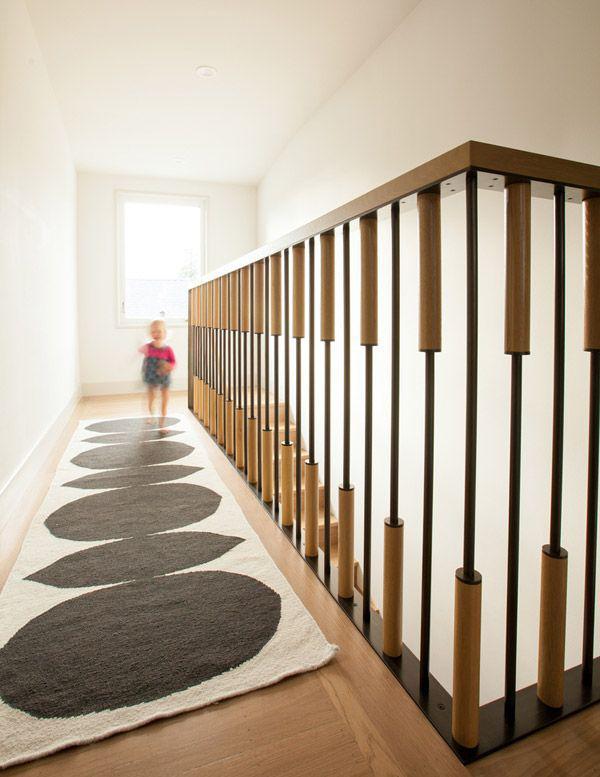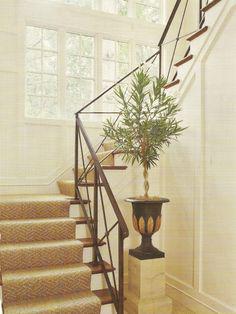The first image is the image on the left, the second image is the image on the right. For the images shown, is this caption "The right image shows a staircase with white 'spindles' and a brown handrail that zigs and zags instead of ascending with no turns." true? Answer yes or no. No. 